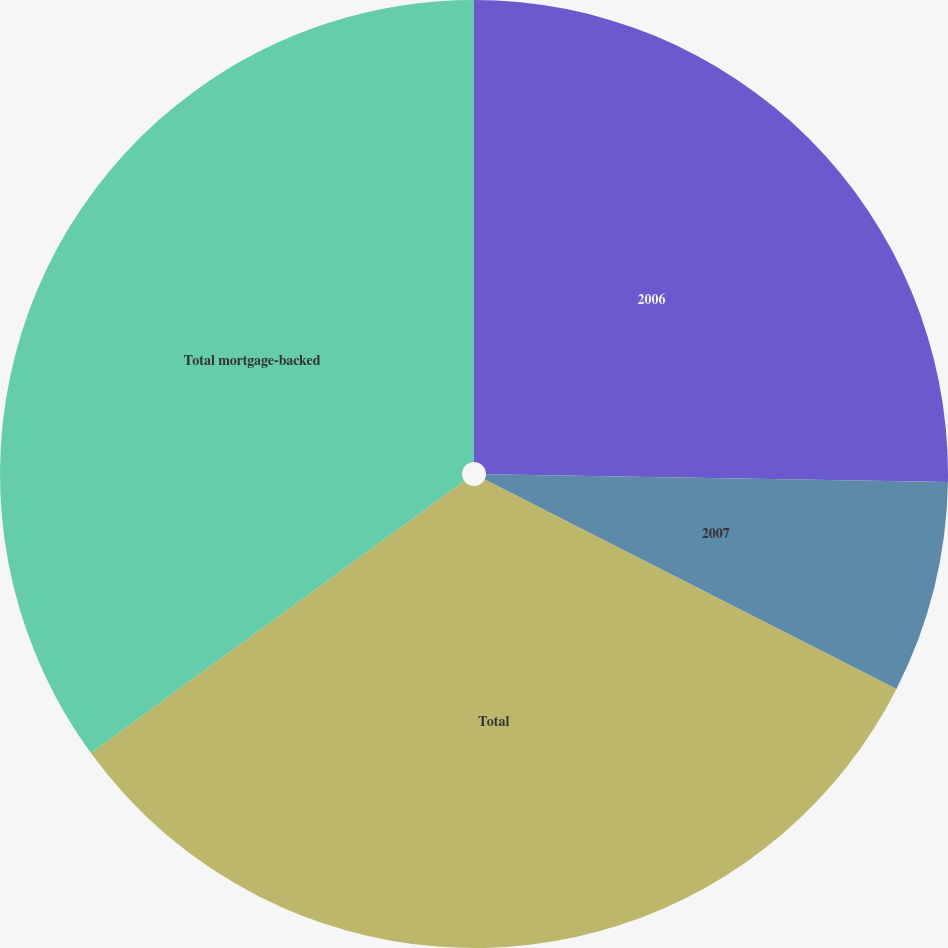<chart> <loc_0><loc_0><loc_500><loc_500><pie_chart><fcel>2006<fcel>2007<fcel>Total<fcel>Total mortgage-backed<nl><fcel>25.27%<fcel>7.22%<fcel>32.49%<fcel>35.02%<nl></chart> 